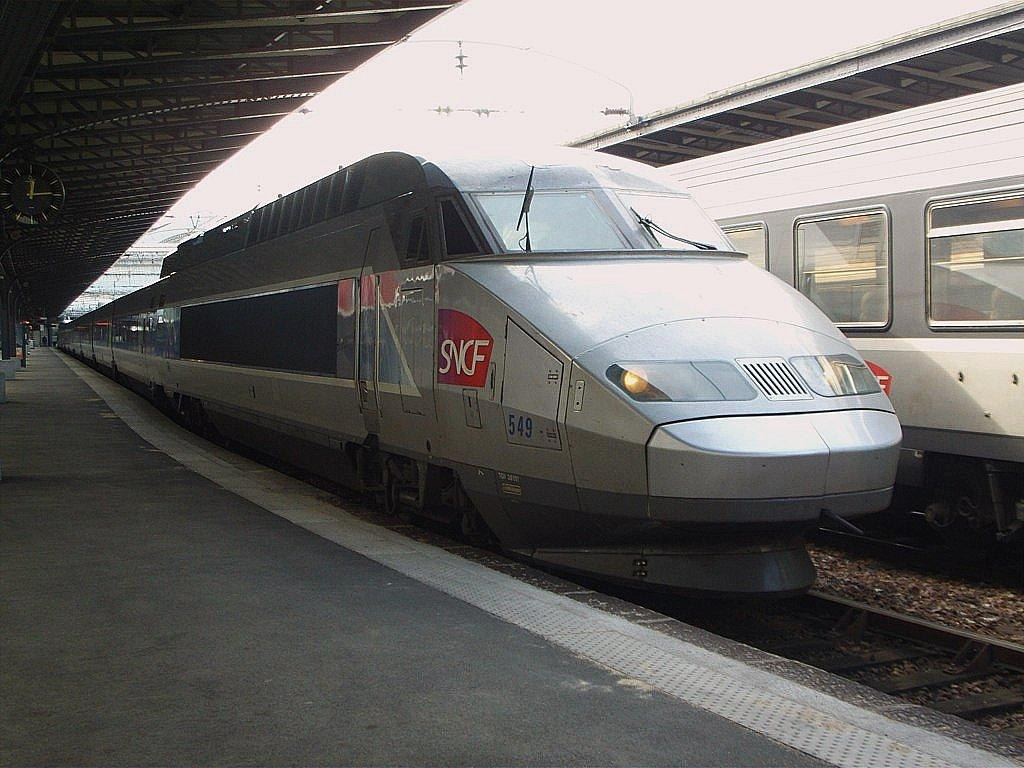Provide a one-sentence caption for the provided image. A silver bullet train is at the station and says SNCF on the side. 